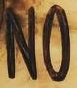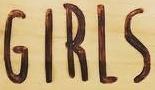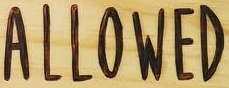Read the text from these images in sequence, separated by a semicolon. NO; GIRLS; ALLOWED 